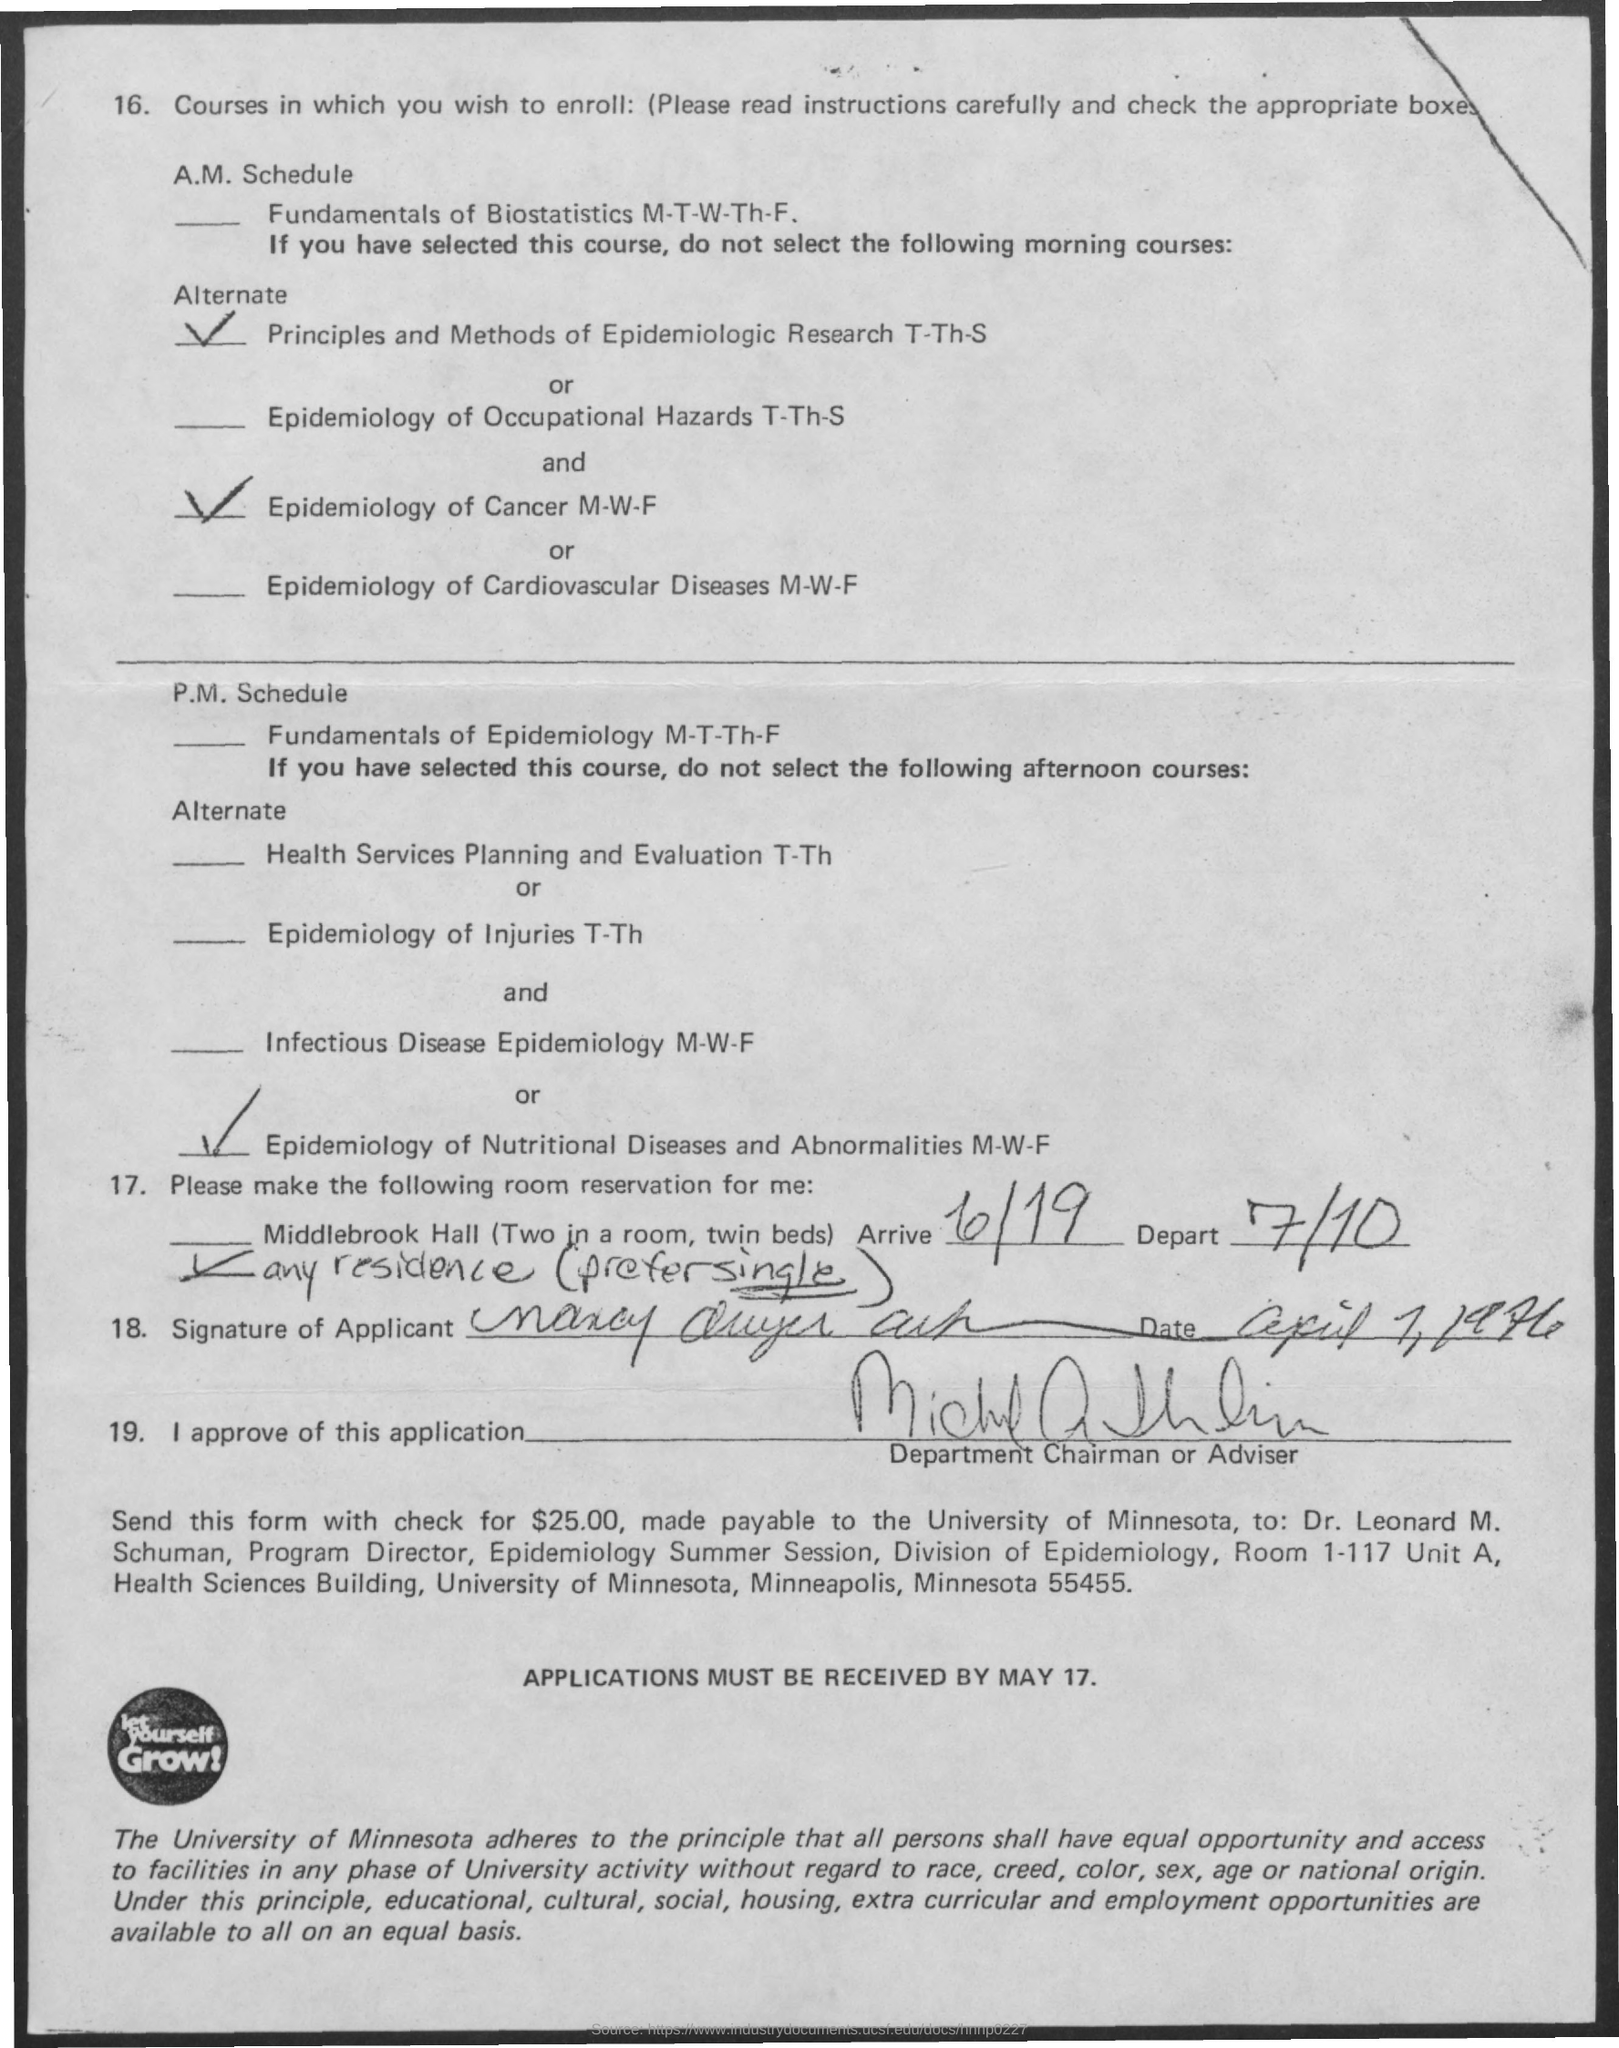What is the arrive date ?
Offer a very short reply. 6/19. What is the depart date ?
Offer a terse response. 7/10. What is the name of the university
Offer a terse response. University of Minnesota. Who is the program director ?
Provide a short and direct response. Dr. Leonard M. Schuman. By when the applications must be received ?
Your answer should be very brief. May 17. How much amount has to be paid in the form of check ?
Your answer should be compact. $25.00. What is the name of the session ?
Provide a succinct answer. Epidemiology summer session. 